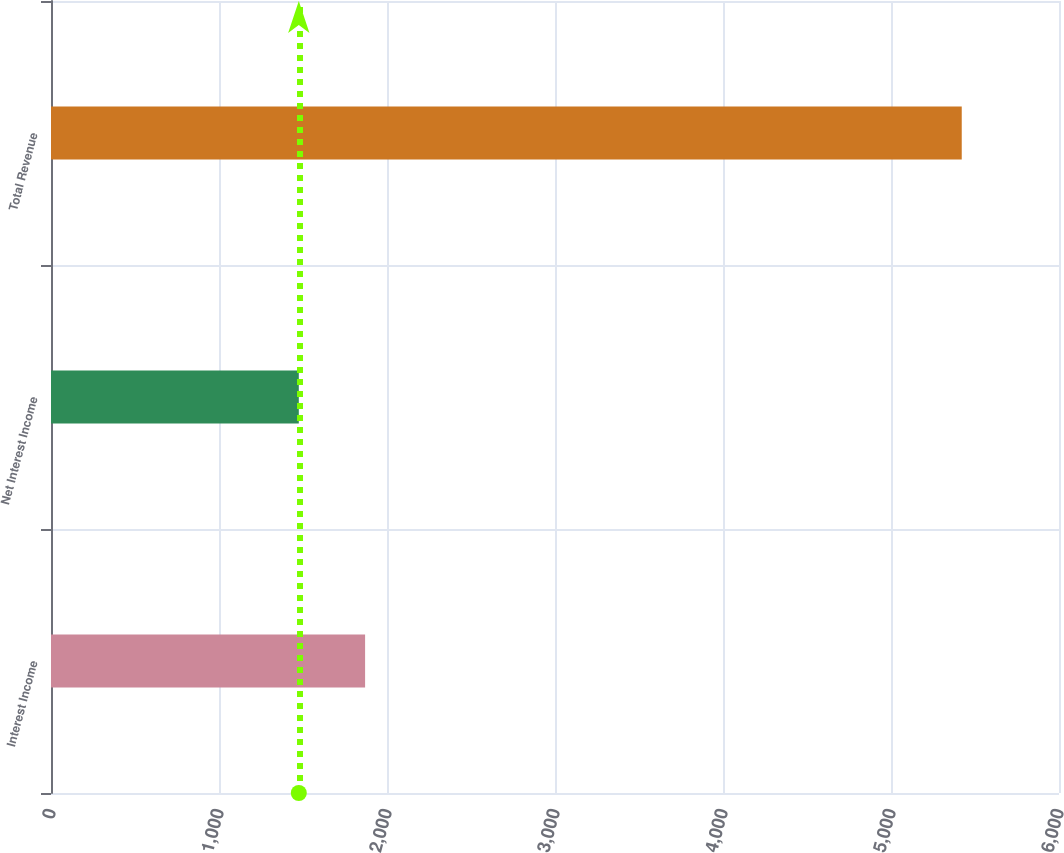<chart> <loc_0><loc_0><loc_500><loc_500><bar_chart><fcel>Interest Income<fcel>Net Interest Income<fcel>Total Revenue<nl><fcel>1869.61<fcel>1475<fcel>5421.1<nl></chart> 